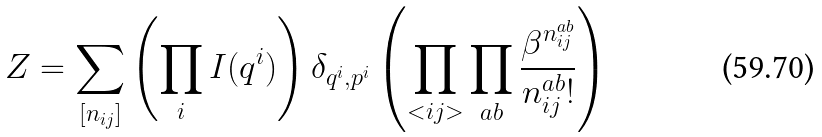<formula> <loc_0><loc_0><loc_500><loc_500>Z = \sum _ { [ n _ { i j } ] } \left ( \prod _ { i } I ( q ^ { i } ) \right ) \delta _ { q ^ { i } , p ^ { i } } \left ( \prod _ { < i j > } \prod _ { a b } \frac { \beta ^ { n ^ { a b } _ { i j } } } { n ^ { a b } _ { i j } ! } \right )</formula> 